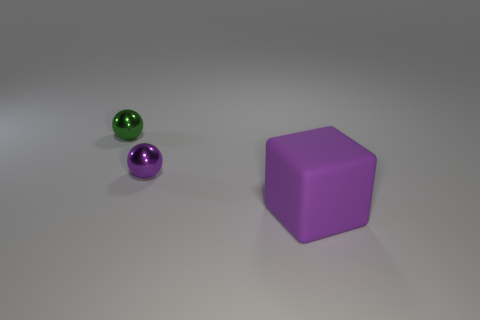Add 3 shiny balls. How many objects exist? 6 Subtract all green spheres. How many spheres are left? 1 Subtract all balls. How many objects are left? 1 Subtract 1 cubes. How many cubes are left? 0 Subtract all cyan cubes. Subtract all blue cylinders. How many cubes are left? 1 Subtract all purple cylinders. How many cyan blocks are left? 0 Subtract all tiny purple spheres. Subtract all tiny purple shiny objects. How many objects are left? 1 Add 3 purple objects. How many purple objects are left? 5 Add 2 large matte blocks. How many large matte blocks exist? 3 Subtract 0 cyan blocks. How many objects are left? 3 